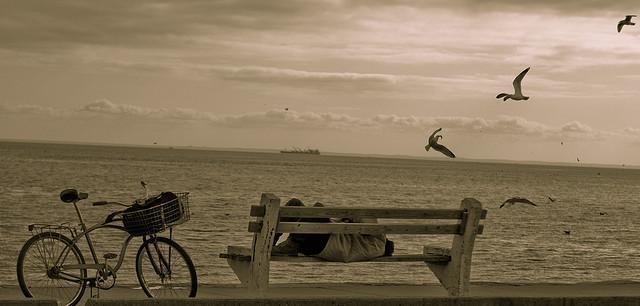How many birds are in the picture?
Give a very brief answer. 4. How many bikes are in this scene?
Give a very brief answer. 1. How many doors does the bus have?
Give a very brief answer. 0. 